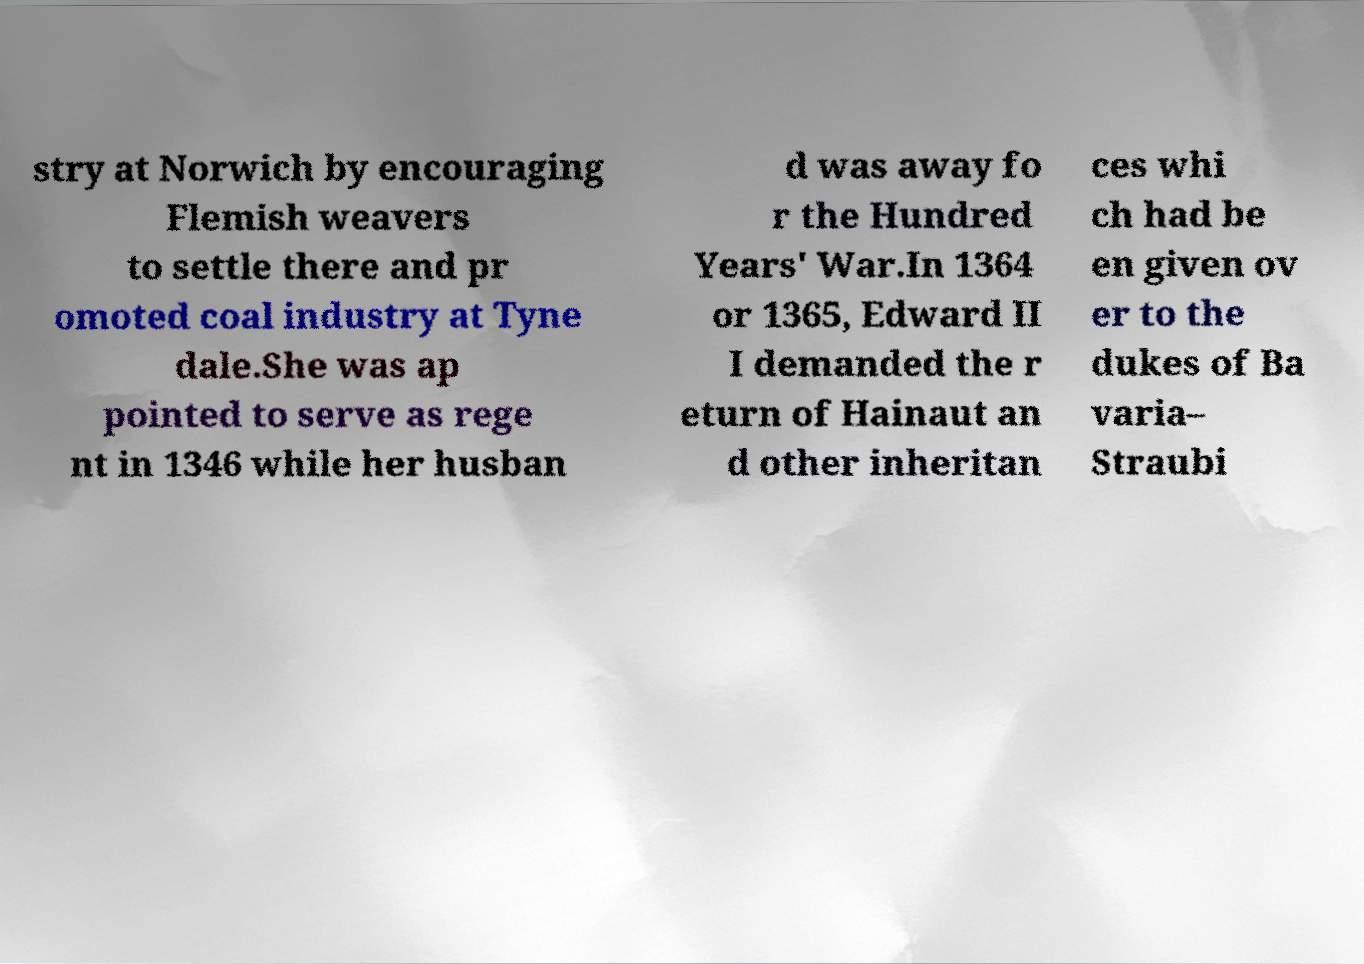Could you extract and type out the text from this image? stry at Norwich by encouraging Flemish weavers to settle there and pr omoted coal industry at Tyne dale.She was ap pointed to serve as rege nt in 1346 while her husban d was away fo r the Hundred Years' War.In 1364 or 1365, Edward II I demanded the r eturn of Hainaut an d other inheritan ces whi ch had be en given ov er to the dukes of Ba varia– Straubi 